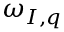Convert formula to latex. <formula><loc_0><loc_0><loc_500><loc_500>\omega _ { I , q }</formula> 